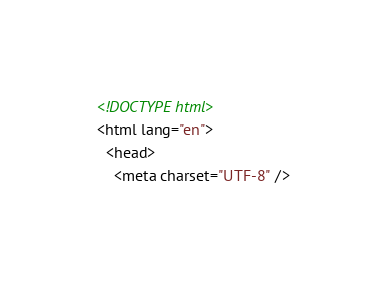<code> <loc_0><loc_0><loc_500><loc_500><_HTML_><!DOCTYPE html>
<html lang="en">
  <head>
    <meta charset="UTF-8" /></code> 